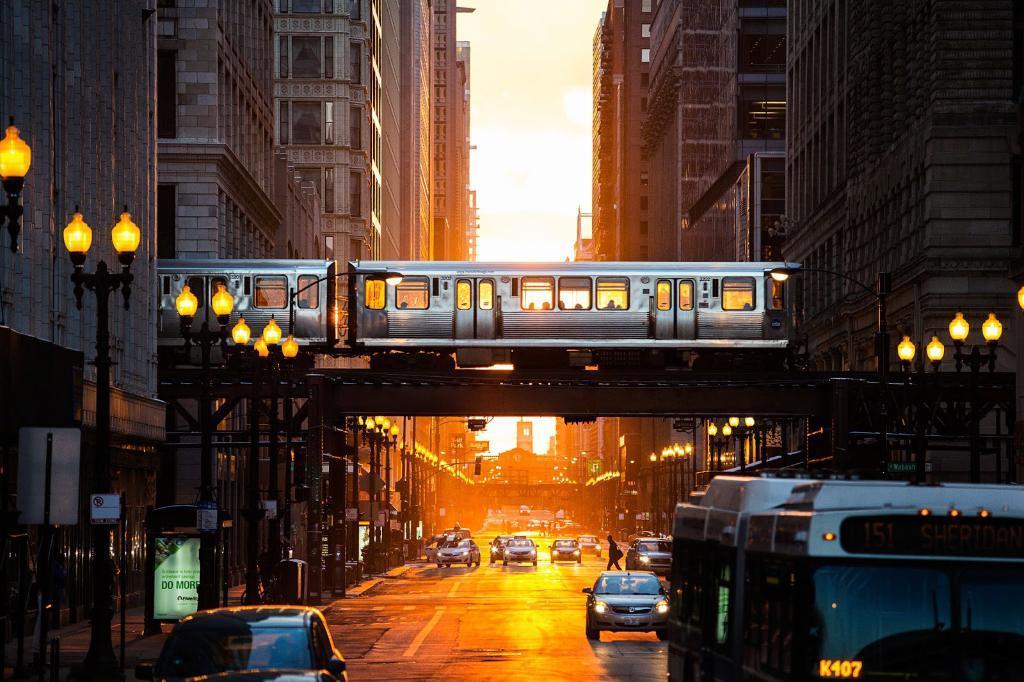Could you give a brief overview of what you see in this image? In the center of the image, we can see a train on the bridge and in the background, there are buildings, lights, name boards and sign boards. At the bottom, we can see vehicles, poles and some people on the road. At the top, there is sky. 